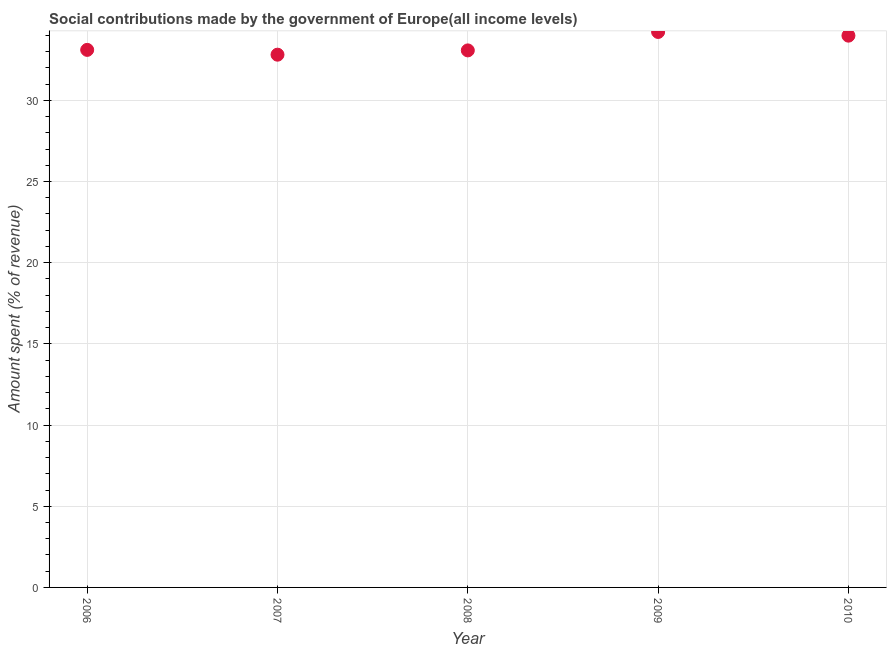What is the amount spent in making social contributions in 2008?
Your answer should be compact. 33.08. Across all years, what is the maximum amount spent in making social contributions?
Your answer should be very brief. 34.21. Across all years, what is the minimum amount spent in making social contributions?
Provide a short and direct response. 32.81. In which year was the amount spent in making social contributions maximum?
Ensure brevity in your answer.  2009. What is the sum of the amount spent in making social contributions?
Offer a very short reply. 167.19. What is the difference between the amount spent in making social contributions in 2006 and 2007?
Offer a terse response. 0.3. What is the average amount spent in making social contributions per year?
Offer a very short reply. 33.44. What is the median amount spent in making social contributions?
Make the answer very short. 33.11. Do a majority of the years between 2007 and 2010 (inclusive) have amount spent in making social contributions greater than 2 %?
Offer a terse response. Yes. What is the ratio of the amount spent in making social contributions in 2006 to that in 2008?
Keep it short and to the point. 1. Is the difference between the amount spent in making social contributions in 2006 and 2010 greater than the difference between any two years?
Offer a very short reply. No. What is the difference between the highest and the second highest amount spent in making social contributions?
Your answer should be compact. 0.23. Is the sum of the amount spent in making social contributions in 2006 and 2010 greater than the maximum amount spent in making social contributions across all years?
Your answer should be very brief. Yes. What is the difference between the highest and the lowest amount spent in making social contributions?
Offer a terse response. 1.4. In how many years, is the amount spent in making social contributions greater than the average amount spent in making social contributions taken over all years?
Make the answer very short. 2. Does the amount spent in making social contributions monotonically increase over the years?
Provide a succinct answer. No. How many dotlines are there?
Ensure brevity in your answer.  1. What is the difference between two consecutive major ticks on the Y-axis?
Your answer should be compact. 5. Are the values on the major ticks of Y-axis written in scientific E-notation?
Make the answer very short. No. Does the graph contain any zero values?
Make the answer very short. No. What is the title of the graph?
Offer a very short reply. Social contributions made by the government of Europe(all income levels). What is the label or title of the X-axis?
Provide a succinct answer. Year. What is the label or title of the Y-axis?
Your answer should be very brief. Amount spent (% of revenue). What is the Amount spent (% of revenue) in 2006?
Ensure brevity in your answer.  33.11. What is the Amount spent (% of revenue) in 2007?
Make the answer very short. 32.81. What is the Amount spent (% of revenue) in 2008?
Provide a short and direct response. 33.08. What is the Amount spent (% of revenue) in 2009?
Give a very brief answer. 34.21. What is the Amount spent (% of revenue) in 2010?
Offer a terse response. 33.98. What is the difference between the Amount spent (% of revenue) in 2006 and 2007?
Keep it short and to the point. 0.3. What is the difference between the Amount spent (% of revenue) in 2006 and 2008?
Keep it short and to the point. 0.03. What is the difference between the Amount spent (% of revenue) in 2006 and 2009?
Give a very brief answer. -1.1. What is the difference between the Amount spent (% of revenue) in 2006 and 2010?
Your response must be concise. -0.88. What is the difference between the Amount spent (% of revenue) in 2007 and 2008?
Keep it short and to the point. -0.26. What is the difference between the Amount spent (% of revenue) in 2007 and 2009?
Make the answer very short. -1.4. What is the difference between the Amount spent (% of revenue) in 2007 and 2010?
Provide a succinct answer. -1.17. What is the difference between the Amount spent (% of revenue) in 2008 and 2009?
Your answer should be very brief. -1.14. What is the difference between the Amount spent (% of revenue) in 2008 and 2010?
Your answer should be compact. -0.91. What is the difference between the Amount spent (% of revenue) in 2009 and 2010?
Make the answer very short. 0.23. What is the ratio of the Amount spent (% of revenue) in 2006 to that in 2007?
Offer a very short reply. 1.01. What is the ratio of the Amount spent (% of revenue) in 2006 to that in 2008?
Your response must be concise. 1. What is the ratio of the Amount spent (% of revenue) in 2006 to that in 2010?
Give a very brief answer. 0.97. What is the ratio of the Amount spent (% of revenue) in 2007 to that in 2008?
Give a very brief answer. 0.99. What is the ratio of the Amount spent (% of revenue) in 2007 to that in 2010?
Give a very brief answer. 0.97. What is the ratio of the Amount spent (% of revenue) in 2008 to that in 2009?
Your answer should be compact. 0.97. 